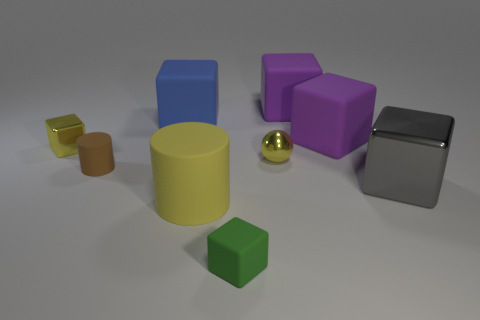What number of blue things are metallic things or rubber blocks?
Keep it short and to the point. 1. How many other things are there of the same color as the sphere?
Your answer should be compact. 2. Are there fewer shiny spheres in front of the tiny yellow metal block than green rubber objects?
Keep it short and to the point. No. What is the color of the tiny block to the right of the blue thing that is on the left side of the metal cube on the right side of the small green block?
Provide a short and direct response. Green. The blue matte object that is the same shape as the green thing is what size?
Keep it short and to the point. Large. Are there fewer objects that are on the right side of the tiny brown matte cylinder than things that are on the left side of the gray object?
Keep it short and to the point. Yes. What shape is the object that is left of the yellow rubber cylinder and behind the yellow shiny block?
Provide a succinct answer. Cube. There is a gray cube that is the same material as the small yellow sphere; what size is it?
Offer a very short reply. Large. There is a large matte cylinder; does it have the same color as the small shiny thing on the right side of the tiny matte block?
Provide a short and direct response. Yes. There is a large block that is in front of the blue rubber block and behind the yellow metal sphere; what material is it?
Your answer should be compact. Rubber. 